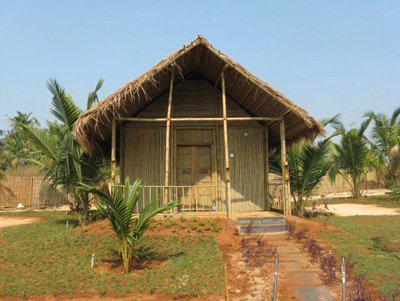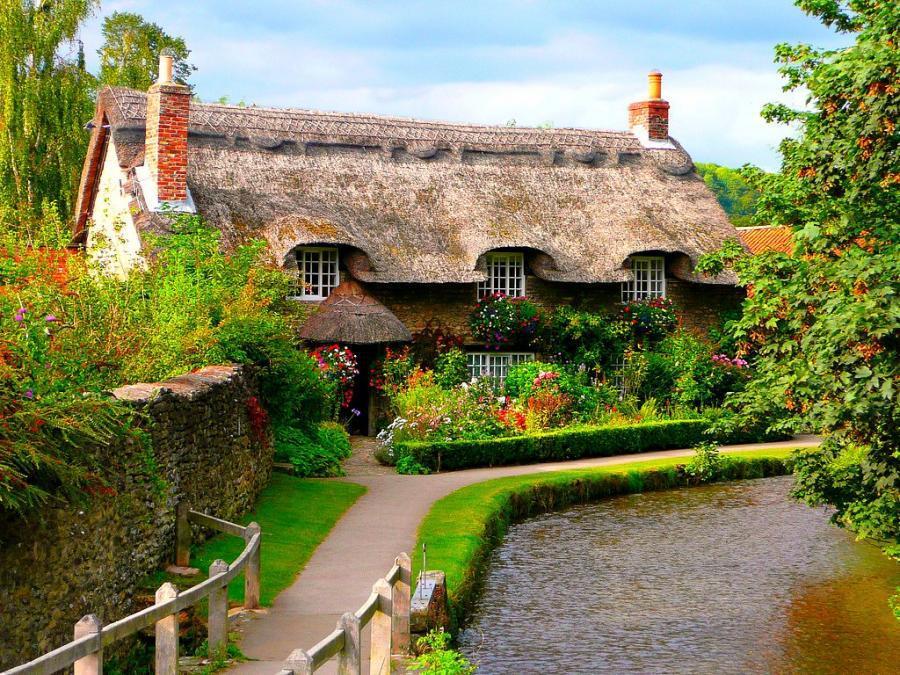The first image is the image on the left, the second image is the image on the right. For the images displayed, is the sentence "A house with a thatched roof is up on stilts." factually correct? Answer yes or no. No. The first image is the image on the left, the second image is the image on the right. Assess this claim about the two images: "The right image contains a tree house.". Correct or not? Answer yes or no. No. 